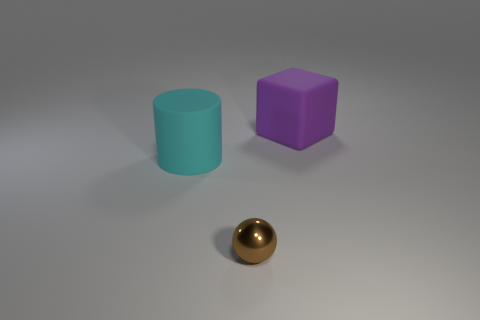What number of things are big cyan objects that are in front of the large purple rubber thing or things that are on the left side of the tiny metal ball?
Ensure brevity in your answer.  1. How many objects are either tiny green blocks or rubber objects?
Your response must be concise. 2. What number of big things are behind the large rubber object right of the metal sphere?
Your answer should be very brief. 0. What number of other objects are the same size as the brown object?
Provide a short and direct response. 0. Is the shape of the big thing that is behind the large cyan matte cylinder the same as  the small metallic thing?
Keep it short and to the point. No. What is the object that is in front of the large cyan matte cylinder made of?
Your answer should be very brief. Metal. Are there any big cyan objects that have the same material as the large purple object?
Provide a short and direct response. Yes. How big is the sphere?
Offer a terse response. Small. What number of blue things are metallic things or large matte blocks?
Give a very brief answer. 0. How many other purple things are the same shape as the big purple matte thing?
Make the answer very short. 0. 